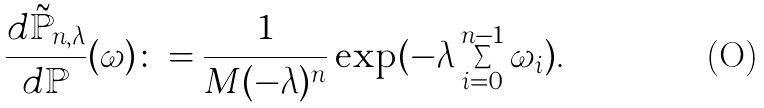<formula> <loc_0><loc_0><loc_500><loc_500>\frac { d \tilde { \mathbb { P } } _ { n , \lambda } } { d \mathbb { P } } ( \omega ) \colon = \frac { 1 } { M ( - \lambda ) ^ { n } } \exp ( - \lambda \sum _ { i = 0 } ^ { n - 1 } \omega _ { i } ) .</formula> 